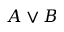Convert formula to latex. <formula><loc_0><loc_0><loc_500><loc_500>A \lor B</formula> 